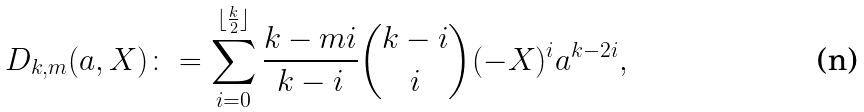Convert formula to latex. <formula><loc_0><loc_0><loc_500><loc_500>D _ { k , m } ( a , X ) \colon = \sum _ { i = 0 } ^ { \lfloor \frac { k } { 2 } \rfloor } \frac { k - m i } { k - i } \binom { k - i } { i } ( - X ) ^ { i } a ^ { k - 2 i } ,</formula> 